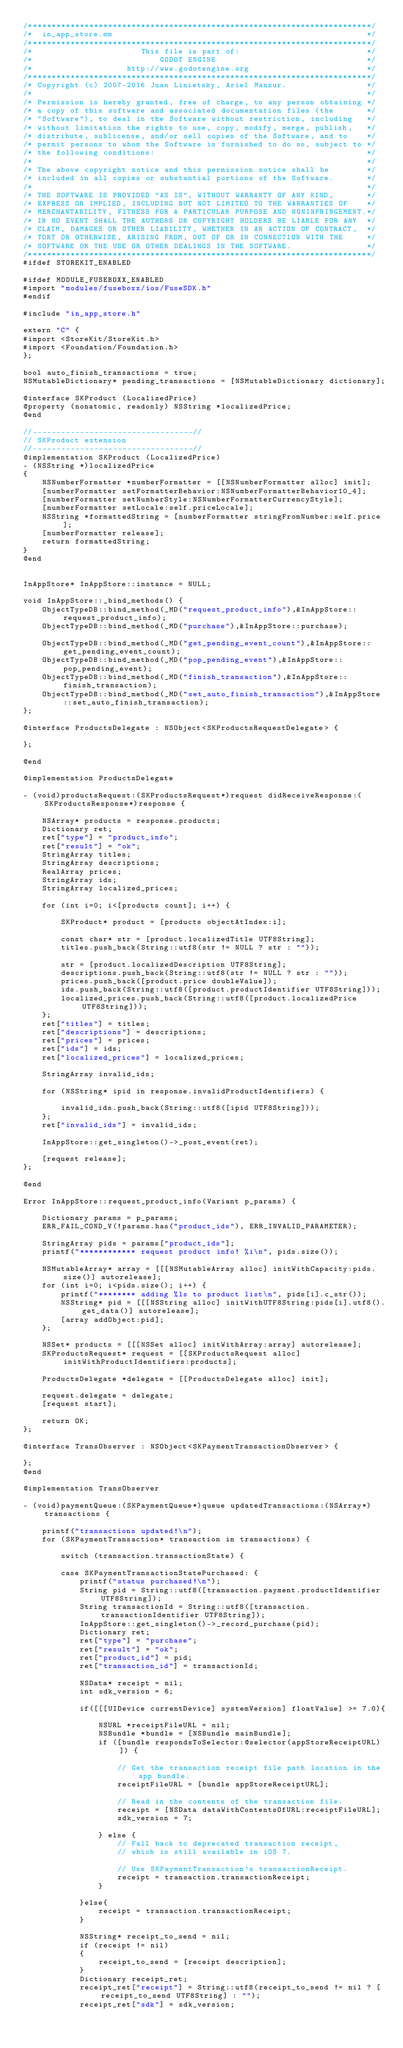<code> <loc_0><loc_0><loc_500><loc_500><_ObjectiveC_>/*************************************************************************/
/*  in_app_store.mm                                                      */
/*************************************************************************/
/*                       This file is part of:                           */
/*                           GODOT ENGINE                                */
/*                    http://www.godotengine.org                         */
/*************************************************************************/
/* Copyright (c) 2007-2016 Juan Linietsky, Ariel Manzur.                 */
/*                                                                       */
/* Permission is hereby granted, free of charge, to any person obtaining */
/* a copy of this software and associated documentation files (the       */
/* "Software"), to deal in the Software without restriction, including   */
/* without limitation the rights to use, copy, modify, merge, publish,   */
/* distribute, sublicense, and/or sell copies of the Software, and to    */
/* permit persons to whom the Software is furnished to do so, subject to */
/* the following conditions:                                             */
/*                                                                       */
/* The above copyright notice and this permission notice shall be        */
/* included in all copies or substantial portions of the Software.       */
/*                                                                       */
/* THE SOFTWARE IS PROVIDED "AS IS", WITHOUT WARRANTY OF ANY KIND,       */
/* EXPRESS OR IMPLIED, INCLUDING BUT NOT LIMITED TO THE WARRANTIES OF    */
/* MERCHANTABILITY, FITNESS FOR A PARTICULAR PURPOSE AND NONINFRINGEMENT.*/
/* IN NO EVENT SHALL THE AUTHORS OR COPYRIGHT HOLDERS BE LIABLE FOR ANY  */
/* CLAIM, DAMAGES OR OTHER LIABILITY, WHETHER IN AN ACTION OF CONTRACT,  */
/* TORT OR OTHERWISE, ARISING FROM, OUT OF OR IN CONNECTION WITH THE     */
/* SOFTWARE OR THE USE OR OTHER DEALINGS IN THE SOFTWARE.                */
/*************************************************************************/
#ifdef STOREKIT_ENABLED

#ifdef MODULE_FUSEBOXX_ENABLED
#import "modules/fuseboxx/ios/FuseSDK.h"
#endif

#include "in_app_store.h"

extern "C" {
#import <StoreKit/StoreKit.h>
#import <Foundation/Foundation.h>
};

bool auto_finish_transactions = true;
NSMutableDictionary* pending_transactions = [NSMutableDictionary dictionary];

@interface SKProduct (LocalizedPrice)
@property (nonatomic, readonly) NSString *localizedPrice;
@end

//----------------------------------//
// SKProduct extension
//----------------------------------//
@implementation SKProduct (LocalizedPrice)
- (NSString *)localizedPrice
{
	NSNumberFormatter *numberFormatter = [[NSNumberFormatter alloc] init];
	[numberFormatter setFormatterBehavior:NSNumberFormatterBehavior10_4];
	[numberFormatter setNumberStyle:NSNumberFormatterCurrencyStyle];
	[numberFormatter setLocale:self.priceLocale];
	NSString *formattedString = [numberFormatter stringFromNumber:self.price];
	[numberFormatter release];
	return formattedString;
}
@end


InAppStore* InAppStore::instance = NULL;

void InAppStore::_bind_methods() {
	ObjectTypeDB::bind_method(_MD("request_product_info"),&InAppStore::request_product_info);
	ObjectTypeDB::bind_method(_MD("purchase"),&InAppStore::purchase);

	ObjectTypeDB::bind_method(_MD("get_pending_event_count"),&InAppStore::get_pending_event_count);
	ObjectTypeDB::bind_method(_MD("pop_pending_event"),&InAppStore::pop_pending_event);
	ObjectTypeDB::bind_method(_MD("finish_transaction"),&InAppStore::finish_transaction);
	ObjectTypeDB::bind_method(_MD("set_auto_finish_transaction"),&InAppStore::set_auto_finish_transaction);
};

@interface ProductsDelegate : NSObject<SKProductsRequestDelegate> {

};

@end

@implementation ProductsDelegate

- (void)productsRequest:(SKProductsRequest*)request didReceiveResponse:(SKProductsResponse*)response {

	NSArray* products = response.products;
	Dictionary ret;
	ret["type"] = "product_info";
	ret["result"] = "ok";
	StringArray titles;
	StringArray descriptions;
	RealArray prices;
	StringArray ids;
	StringArray localized_prices;

	for (int i=0; i<[products count]; i++) {

		SKProduct* product = [products objectAtIndex:i];

		const char* str = [product.localizedTitle UTF8String];
		titles.push_back(String::utf8(str != NULL ? str : ""));

		str = [product.localizedDescription UTF8String];
		descriptions.push_back(String::utf8(str != NULL ? str : ""));
		prices.push_back([product.price doubleValue]);
		ids.push_back(String::utf8([product.productIdentifier UTF8String]));
		localized_prices.push_back(String::utf8([product.localizedPrice UTF8String]));
	};
	ret["titles"] = titles;
	ret["descriptions"] = descriptions;
	ret["prices"] = prices;
	ret["ids"] = ids;
	ret["localized_prices"] = localized_prices;

	StringArray invalid_ids;

	for (NSString* ipid in response.invalidProductIdentifiers) {

		invalid_ids.push_back(String::utf8([ipid UTF8String]));
	};
	ret["invalid_ids"] = invalid_ids;

	InAppStore::get_singleton()->_post_event(ret);

	[request release];
};

@end

Error InAppStore::request_product_info(Variant p_params) {

	Dictionary params = p_params;
	ERR_FAIL_COND_V(!params.has("product_ids"), ERR_INVALID_PARAMETER);

	StringArray pids = params["product_ids"];
	printf("************ request product info! %i\n", pids.size());

	NSMutableArray* array = [[[NSMutableArray alloc] initWithCapacity:pids.size()] autorelease];
	for (int i=0; i<pids.size(); i++) {
		printf("******** adding %ls to product list\n", pids[i].c_str());
		NSString* pid = [[[NSString alloc] initWithUTF8String:pids[i].utf8().get_data()] autorelease];
		[array addObject:pid];
	};

	NSSet* products = [[[NSSet alloc] initWithArray:array] autorelease];
	SKProductsRequest* request = [[SKProductsRequest alloc] initWithProductIdentifiers:products];

	ProductsDelegate *delegate = [[ProductsDelegate alloc] init];

	request.delegate = delegate;
	[request start];

	return OK;
};

@interface TransObserver : NSObject<SKPaymentTransactionObserver> {

};
@end

@implementation TransObserver

- (void)paymentQueue:(SKPaymentQueue*)queue updatedTransactions:(NSArray*) transactions {

    printf("transactions updated!\n");
	for (SKPaymentTransaction* transaction in transactions) {

		switch (transaction.transactionState) {

		case SKPaymentTransactionStatePurchased: {
            printf("status purchased!\n");
			String pid = String::utf8([transaction.payment.productIdentifier UTF8String]);
            String transactionId = String::utf8([transaction.transactionIdentifier UTF8String]);
			InAppStore::get_singleton()->_record_purchase(pid);
			Dictionary ret;
			ret["type"] = "purchase";
			ret["result"] = "ok";
			ret["product_id"] = pid;
            ret["transaction_id"] = transactionId;
            
            NSData* receipt = nil;
            int sdk_version = 6;
            
            if([[[UIDevice currentDevice] systemVersion] floatValue] >= 7.0){
                
                NSURL *receiptFileURL = nil;
                NSBundle *bundle = [NSBundle mainBundle];
                if ([bundle respondsToSelector:@selector(appStoreReceiptURL)]) {
                    
                    // Get the transaction receipt file path location in the app bundle.
                    receiptFileURL = [bundle appStoreReceiptURL];
                    
                    // Read in the contents of the transaction file.
                    receipt = [NSData dataWithContentsOfURL:receiptFileURL];
                    sdk_version = 7;
                    
                } else {
                    // Fall back to deprecated transaction receipt,
                    // which is still available in iOS 7.
                    
                    // Use SKPaymentTransaction's transactionReceipt.
                    receipt = transaction.transactionReceipt;
                }
                
            }else{
                receipt = transaction.transactionReceipt;
            }
            
            NSString* receipt_to_send = nil;
            if (receipt != nil)
            {
                receipt_to_send = [receipt description];
            }
            Dictionary receipt_ret;
            receipt_ret["receipt"] = String::utf8(receipt_to_send != nil ? [receipt_to_send UTF8String] : "");
            receipt_ret["sdk"] = sdk_version;</code> 